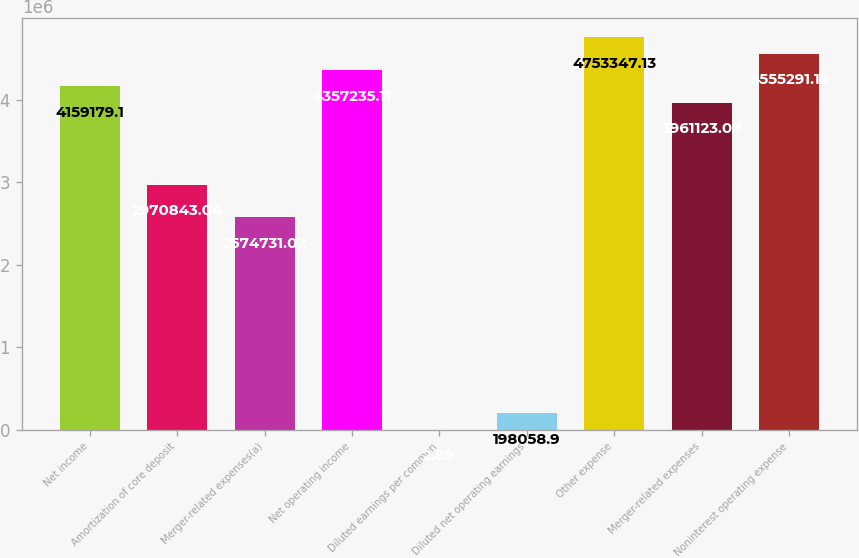Convert chart to OTSL. <chart><loc_0><loc_0><loc_500><loc_500><bar_chart><fcel>Net income<fcel>Amortization of core deposit<fcel>Merger-related expenses(a)<fcel>Net operating income<fcel>Diluted earnings per common<fcel>Diluted net operating earnings<fcel>Other expense<fcel>Merger-related expenses<fcel>Noninterest operating expense<nl><fcel>4.15918e+06<fcel>2.97084e+06<fcel>2.57473e+06<fcel>4.35724e+06<fcel>2.89<fcel>198059<fcel>4.75335e+06<fcel>3.96112e+06<fcel>4.55529e+06<nl></chart> 